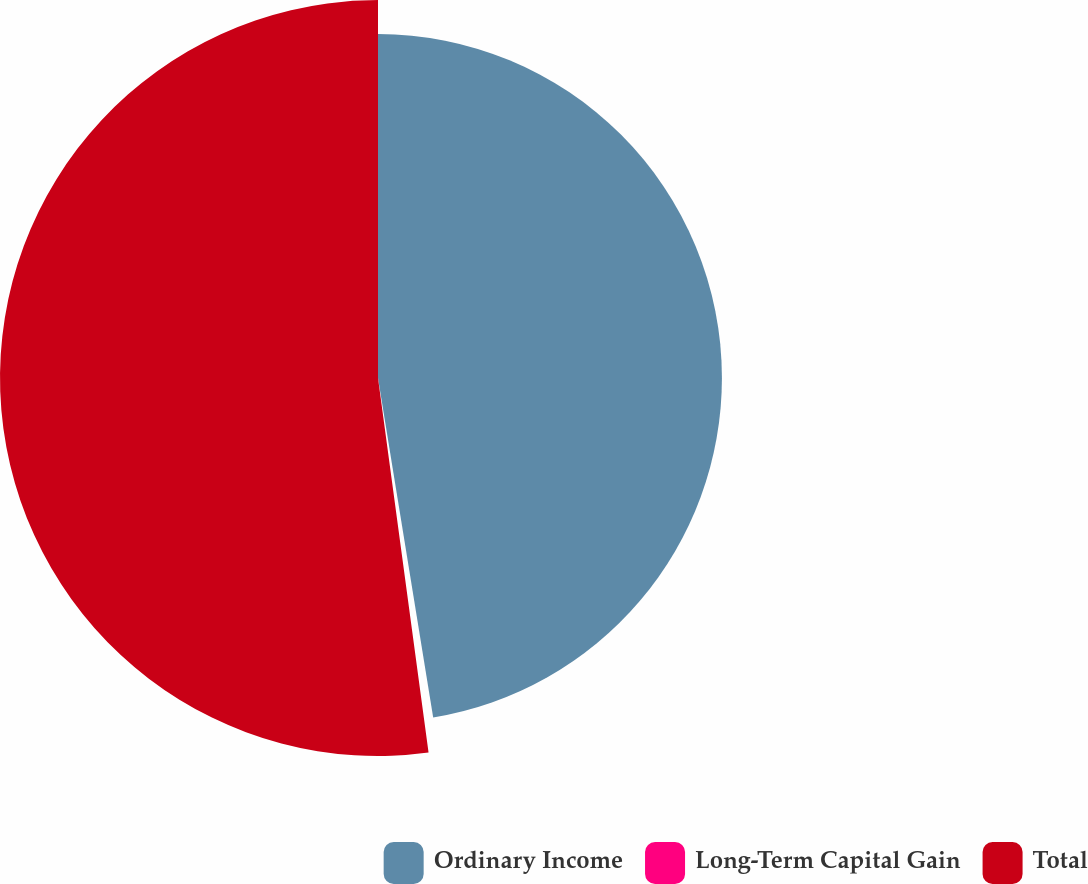Convert chart. <chart><loc_0><loc_0><loc_500><loc_500><pie_chart><fcel>Ordinary Income<fcel>Long-Term Capital Gain<fcel>Total<nl><fcel>47.43%<fcel>0.43%<fcel>52.13%<nl></chart> 